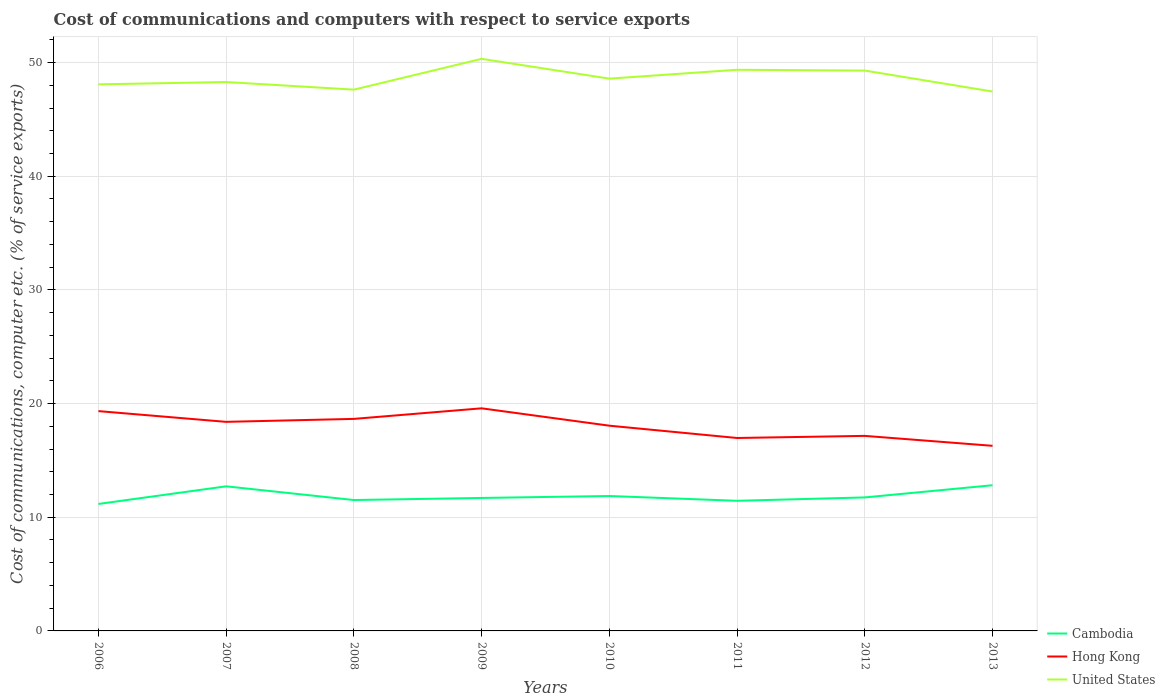How many different coloured lines are there?
Offer a terse response. 3. Does the line corresponding to Hong Kong intersect with the line corresponding to Cambodia?
Your response must be concise. No. Is the number of lines equal to the number of legend labels?
Make the answer very short. Yes. Across all years, what is the maximum cost of communications and computers in Hong Kong?
Your answer should be very brief. 16.28. What is the total cost of communications and computers in Cambodia in the graph?
Offer a very short reply. 0.07. What is the difference between the highest and the second highest cost of communications and computers in Hong Kong?
Provide a short and direct response. 3.3. What is the difference between the highest and the lowest cost of communications and computers in Hong Kong?
Provide a succinct answer. 5. Is the cost of communications and computers in Hong Kong strictly greater than the cost of communications and computers in Cambodia over the years?
Provide a short and direct response. No. How many lines are there?
Your answer should be compact. 3. How many years are there in the graph?
Provide a succinct answer. 8. What is the difference between two consecutive major ticks on the Y-axis?
Make the answer very short. 10. Does the graph contain any zero values?
Your answer should be very brief. No. How are the legend labels stacked?
Offer a very short reply. Vertical. What is the title of the graph?
Offer a terse response. Cost of communications and computers with respect to service exports. What is the label or title of the Y-axis?
Make the answer very short. Cost of communications, computer etc. (% of service exports). What is the Cost of communications, computer etc. (% of service exports) in Cambodia in 2006?
Provide a short and direct response. 11.17. What is the Cost of communications, computer etc. (% of service exports) of Hong Kong in 2006?
Provide a succinct answer. 19.34. What is the Cost of communications, computer etc. (% of service exports) of United States in 2006?
Your answer should be compact. 48.08. What is the Cost of communications, computer etc. (% of service exports) of Cambodia in 2007?
Offer a terse response. 12.72. What is the Cost of communications, computer etc. (% of service exports) of Hong Kong in 2007?
Give a very brief answer. 18.39. What is the Cost of communications, computer etc. (% of service exports) of United States in 2007?
Give a very brief answer. 48.29. What is the Cost of communications, computer etc. (% of service exports) of Cambodia in 2008?
Provide a short and direct response. 11.52. What is the Cost of communications, computer etc. (% of service exports) of Hong Kong in 2008?
Provide a short and direct response. 18.65. What is the Cost of communications, computer etc. (% of service exports) of United States in 2008?
Make the answer very short. 47.62. What is the Cost of communications, computer etc. (% of service exports) of Cambodia in 2009?
Your answer should be compact. 11.7. What is the Cost of communications, computer etc. (% of service exports) of Hong Kong in 2009?
Ensure brevity in your answer.  19.58. What is the Cost of communications, computer etc. (% of service exports) in United States in 2009?
Your response must be concise. 50.33. What is the Cost of communications, computer etc. (% of service exports) in Cambodia in 2010?
Provide a succinct answer. 11.87. What is the Cost of communications, computer etc. (% of service exports) of Hong Kong in 2010?
Offer a very short reply. 18.06. What is the Cost of communications, computer etc. (% of service exports) in United States in 2010?
Give a very brief answer. 48.59. What is the Cost of communications, computer etc. (% of service exports) of Cambodia in 2011?
Ensure brevity in your answer.  11.45. What is the Cost of communications, computer etc. (% of service exports) in Hong Kong in 2011?
Keep it short and to the point. 16.97. What is the Cost of communications, computer etc. (% of service exports) of United States in 2011?
Keep it short and to the point. 49.37. What is the Cost of communications, computer etc. (% of service exports) of Cambodia in 2012?
Your answer should be compact. 11.74. What is the Cost of communications, computer etc. (% of service exports) in Hong Kong in 2012?
Your response must be concise. 17.16. What is the Cost of communications, computer etc. (% of service exports) in United States in 2012?
Make the answer very short. 49.3. What is the Cost of communications, computer etc. (% of service exports) in Cambodia in 2013?
Your answer should be very brief. 12.82. What is the Cost of communications, computer etc. (% of service exports) of Hong Kong in 2013?
Make the answer very short. 16.28. What is the Cost of communications, computer etc. (% of service exports) in United States in 2013?
Provide a short and direct response. 47.45. Across all years, what is the maximum Cost of communications, computer etc. (% of service exports) of Cambodia?
Provide a short and direct response. 12.82. Across all years, what is the maximum Cost of communications, computer etc. (% of service exports) of Hong Kong?
Your answer should be very brief. 19.58. Across all years, what is the maximum Cost of communications, computer etc. (% of service exports) in United States?
Your answer should be very brief. 50.33. Across all years, what is the minimum Cost of communications, computer etc. (% of service exports) of Cambodia?
Ensure brevity in your answer.  11.17. Across all years, what is the minimum Cost of communications, computer etc. (% of service exports) of Hong Kong?
Keep it short and to the point. 16.28. Across all years, what is the minimum Cost of communications, computer etc. (% of service exports) of United States?
Ensure brevity in your answer.  47.45. What is the total Cost of communications, computer etc. (% of service exports) in Cambodia in the graph?
Make the answer very short. 94.98. What is the total Cost of communications, computer etc. (% of service exports) in Hong Kong in the graph?
Provide a succinct answer. 144.44. What is the total Cost of communications, computer etc. (% of service exports) of United States in the graph?
Your response must be concise. 389.03. What is the difference between the Cost of communications, computer etc. (% of service exports) of Cambodia in 2006 and that in 2007?
Keep it short and to the point. -1.55. What is the difference between the Cost of communications, computer etc. (% of service exports) in Hong Kong in 2006 and that in 2007?
Keep it short and to the point. 0.95. What is the difference between the Cost of communications, computer etc. (% of service exports) of United States in 2006 and that in 2007?
Provide a short and direct response. -0.21. What is the difference between the Cost of communications, computer etc. (% of service exports) in Cambodia in 2006 and that in 2008?
Offer a very short reply. -0.34. What is the difference between the Cost of communications, computer etc. (% of service exports) in Hong Kong in 2006 and that in 2008?
Provide a succinct answer. 0.68. What is the difference between the Cost of communications, computer etc. (% of service exports) in United States in 2006 and that in 2008?
Your answer should be very brief. 0.46. What is the difference between the Cost of communications, computer etc. (% of service exports) of Cambodia in 2006 and that in 2009?
Ensure brevity in your answer.  -0.53. What is the difference between the Cost of communications, computer etc. (% of service exports) in Hong Kong in 2006 and that in 2009?
Provide a short and direct response. -0.25. What is the difference between the Cost of communications, computer etc. (% of service exports) of United States in 2006 and that in 2009?
Offer a very short reply. -2.25. What is the difference between the Cost of communications, computer etc. (% of service exports) of Cambodia in 2006 and that in 2010?
Keep it short and to the point. -0.7. What is the difference between the Cost of communications, computer etc. (% of service exports) of Hong Kong in 2006 and that in 2010?
Ensure brevity in your answer.  1.28. What is the difference between the Cost of communications, computer etc. (% of service exports) of United States in 2006 and that in 2010?
Your answer should be very brief. -0.51. What is the difference between the Cost of communications, computer etc. (% of service exports) of Cambodia in 2006 and that in 2011?
Keep it short and to the point. -0.28. What is the difference between the Cost of communications, computer etc. (% of service exports) of Hong Kong in 2006 and that in 2011?
Your answer should be compact. 2.36. What is the difference between the Cost of communications, computer etc. (% of service exports) of United States in 2006 and that in 2011?
Provide a short and direct response. -1.28. What is the difference between the Cost of communications, computer etc. (% of service exports) in Cambodia in 2006 and that in 2012?
Offer a terse response. -0.57. What is the difference between the Cost of communications, computer etc. (% of service exports) in Hong Kong in 2006 and that in 2012?
Your answer should be compact. 2.18. What is the difference between the Cost of communications, computer etc. (% of service exports) of United States in 2006 and that in 2012?
Offer a terse response. -1.21. What is the difference between the Cost of communications, computer etc. (% of service exports) in Cambodia in 2006 and that in 2013?
Provide a short and direct response. -1.65. What is the difference between the Cost of communications, computer etc. (% of service exports) of Hong Kong in 2006 and that in 2013?
Your answer should be compact. 3.05. What is the difference between the Cost of communications, computer etc. (% of service exports) in United States in 2006 and that in 2013?
Your response must be concise. 0.63. What is the difference between the Cost of communications, computer etc. (% of service exports) of Cambodia in 2007 and that in 2008?
Ensure brevity in your answer.  1.21. What is the difference between the Cost of communications, computer etc. (% of service exports) of Hong Kong in 2007 and that in 2008?
Your response must be concise. -0.26. What is the difference between the Cost of communications, computer etc. (% of service exports) in United States in 2007 and that in 2008?
Offer a very short reply. 0.67. What is the difference between the Cost of communications, computer etc. (% of service exports) of Cambodia in 2007 and that in 2009?
Ensure brevity in your answer.  1.02. What is the difference between the Cost of communications, computer etc. (% of service exports) of Hong Kong in 2007 and that in 2009?
Make the answer very short. -1.19. What is the difference between the Cost of communications, computer etc. (% of service exports) in United States in 2007 and that in 2009?
Provide a short and direct response. -2.04. What is the difference between the Cost of communications, computer etc. (% of service exports) of Cambodia in 2007 and that in 2010?
Your answer should be very brief. 0.85. What is the difference between the Cost of communications, computer etc. (% of service exports) of Hong Kong in 2007 and that in 2010?
Offer a terse response. 0.34. What is the difference between the Cost of communications, computer etc. (% of service exports) in United States in 2007 and that in 2010?
Provide a succinct answer. -0.3. What is the difference between the Cost of communications, computer etc. (% of service exports) in Cambodia in 2007 and that in 2011?
Your answer should be compact. 1.27. What is the difference between the Cost of communications, computer etc. (% of service exports) of Hong Kong in 2007 and that in 2011?
Offer a terse response. 1.42. What is the difference between the Cost of communications, computer etc. (% of service exports) in United States in 2007 and that in 2011?
Provide a succinct answer. -1.08. What is the difference between the Cost of communications, computer etc. (% of service exports) in Cambodia in 2007 and that in 2012?
Provide a succinct answer. 0.98. What is the difference between the Cost of communications, computer etc. (% of service exports) in Hong Kong in 2007 and that in 2012?
Give a very brief answer. 1.23. What is the difference between the Cost of communications, computer etc. (% of service exports) in United States in 2007 and that in 2012?
Your answer should be very brief. -1.01. What is the difference between the Cost of communications, computer etc. (% of service exports) of Cambodia in 2007 and that in 2013?
Your answer should be compact. -0.1. What is the difference between the Cost of communications, computer etc. (% of service exports) in Hong Kong in 2007 and that in 2013?
Give a very brief answer. 2.11. What is the difference between the Cost of communications, computer etc. (% of service exports) of United States in 2007 and that in 2013?
Your response must be concise. 0.84. What is the difference between the Cost of communications, computer etc. (% of service exports) of Cambodia in 2008 and that in 2009?
Offer a terse response. -0.18. What is the difference between the Cost of communications, computer etc. (% of service exports) of Hong Kong in 2008 and that in 2009?
Provide a short and direct response. -0.93. What is the difference between the Cost of communications, computer etc. (% of service exports) in United States in 2008 and that in 2009?
Make the answer very short. -2.71. What is the difference between the Cost of communications, computer etc. (% of service exports) of Cambodia in 2008 and that in 2010?
Your answer should be very brief. -0.35. What is the difference between the Cost of communications, computer etc. (% of service exports) of Hong Kong in 2008 and that in 2010?
Offer a very short reply. 0.6. What is the difference between the Cost of communications, computer etc. (% of service exports) in United States in 2008 and that in 2010?
Your answer should be very brief. -0.97. What is the difference between the Cost of communications, computer etc. (% of service exports) in Cambodia in 2008 and that in 2011?
Your response must be concise. 0.07. What is the difference between the Cost of communications, computer etc. (% of service exports) of Hong Kong in 2008 and that in 2011?
Keep it short and to the point. 1.68. What is the difference between the Cost of communications, computer etc. (% of service exports) of United States in 2008 and that in 2011?
Ensure brevity in your answer.  -1.75. What is the difference between the Cost of communications, computer etc. (% of service exports) of Cambodia in 2008 and that in 2012?
Keep it short and to the point. -0.23. What is the difference between the Cost of communications, computer etc. (% of service exports) of Hong Kong in 2008 and that in 2012?
Offer a very short reply. 1.49. What is the difference between the Cost of communications, computer etc. (% of service exports) in United States in 2008 and that in 2012?
Make the answer very short. -1.68. What is the difference between the Cost of communications, computer etc. (% of service exports) of Cambodia in 2008 and that in 2013?
Keep it short and to the point. -1.3. What is the difference between the Cost of communications, computer etc. (% of service exports) in Hong Kong in 2008 and that in 2013?
Your answer should be very brief. 2.37. What is the difference between the Cost of communications, computer etc. (% of service exports) in United States in 2008 and that in 2013?
Your answer should be compact. 0.17. What is the difference between the Cost of communications, computer etc. (% of service exports) of Cambodia in 2009 and that in 2010?
Keep it short and to the point. -0.17. What is the difference between the Cost of communications, computer etc. (% of service exports) in Hong Kong in 2009 and that in 2010?
Offer a very short reply. 1.53. What is the difference between the Cost of communications, computer etc. (% of service exports) in United States in 2009 and that in 2010?
Keep it short and to the point. 1.74. What is the difference between the Cost of communications, computer etc. (% of service exports) in Cambodia in 2009 and that in 2011?
Make the answer very short. 0.25. What is the difference between the Cost of communications, computer etc. (% of service exports) in Hong Kong in 2009 and that in 2011?
Your response must be concise. 2.61. What is the difference between the Cost of communications, computer etc. (% of service exports) in United States in 2009 and that in 2011?
Provide a short and direct response. 0.96. What is the difference between the Cost of communications, computer etc. (% of service exports) in Cambodia in 2009 and that in 2012?
Your answer should be compact. -0.05. What is the difference between the Cost of communications, computer etc. (% of service exports) of Hong Kong in 2009 and that in 2012?
Offer a terse response. 2.42. What is the difference between the Cost of communications, computer etc. (% of service exports) in United States in 2009 and that in 2012?
Ensure brevity in your answer.  1.03. What is the difference between the Cost of communications, computer etc. (% of service exports) of Cambodia in 2009 and that in 2013?
Make the answer very short. -1.12. What is the difference between the Cost of communications, computer etc. (% of service exports) of Hong Kong in 2009 and that in 2013?
Give a very brief answer. 3.3. What is the difference between the Cost of communications, computer etc. (% of service exports) of United States in 2009 and that in 2013?
Your answer should be compact. 2.88. What is the difference between the Cost of communications, computer etc. (% of service exports) of Cambodia in 2010 and that in 2011?
Make the answer very short. 0.42. What is the difference between the Cost of communications, computer etc. (% of service exports) of Hong Kong in 2010 and that in 2011?
Your response must be concise. 1.08. What is the difference between the Cost of communications, computer etc. (% of service exports) of United States in 2010 and that in 2011?
Your answer should be compact. -0.78. What is the difference between the Cost of communications, computer etc. (% of service exports) of Cambodia in 2010 and that in 2012?
Provide a short and direct response. 0.12. What is the difference between the Cost of communications, computer etc. (% of service exports) of Hong Kong in 2010 and that in 2012?
Your answer should be very brief. 0.9. What is the difference between the Cost of communications, computer etc. (% of service exports) in United States in 2010 and that in 2012?
Keep it short and to the point. -0.71. What is the difference between the Cost of communications, computer etc. (% of service exports) in Cambodia in 2010 and that in 2013?
Give a very brief answer. -0.95. What is the difference between the Cost of communications, computer etc. (% of service exports) in Hong Kong in 2010 and that in 2013?
Offer a very short reply. 1.77. What is the difference between the Cost of communications, computer etc. (% of service exports) in United States in 2010 and that in 2013?
Provide a short and direct response. 1.14. What is the difference between the Cost of communications, computer etc. (% of service exports) in Cambodia in 2011 and that in 2012?
Ensure brevity in your answer.  -0.3. What is the difference between the Cost of communications, computer etc. (% of service exports) in Hong Kong in 2011 and that in 2012?
Ensure brevity in your answer.  -0.19. What is the difference between the Cost of communications, computer etc. (% of service exports) of United States in 2011 and that in 2012?
Your answer should be very brief. 0.07. What is the difference between the Cost of communications, computer etc. (% of service exports) of Cambodia in 2011 and that in 2013?
Offer a terse response. -1.37. What is the difference between the Cost of communications, computer etc. (% of service exports) of Hong Kong in 2011 and that in 2013?
Your answer should be compact. 0.69. What is the difference between the Cost of communications, computer etc. (% of service exports) of United States in 2011 and that in 2013?
Provide a succinct answer. 1.91. What is the difference between the Cost of communications, computer etc. (% of service exports) in Cambodia in 2012 and that in 2013?
Make the answer very short. -1.07. What is the difference between the Cost of communications, computer etc. (% of service exports) in Hong Kong in 2012 and that in 2013?
Ensure brevity in your answer.  0.87. What is the difference between the Cost of communications, computer etc. (% of service exports) of United States in 2012 and that in 2013?
Offer a terse response. 1.84. What is the difference between the Cost of communications, computer etc. (% of service exports) of Cambodia in 2006 and the Cost of communications, computer etc. (% of service exports) of Hong Kong in 2007?
Your response must be concise. -7.22. What is the difference between the Cost of communications, computer etc. (% of service exports) of Cambodia in 2006 and the Cost of communications, computer etc. (% of service exports) of United States in 2007?
Your answer should be compact. -37.12. What is the difference between the Cost of communications, computer etc. (% of service exports) of Hong Kong in 2006 and the Cost of communications, computer etc. (% of service exports) of United States in 2007?
Make the answer very short. -28.95. What is the difference between the Cost of communications, computer etc. (% of service exports) of Cambodia in 2006 and the Cost of communications, computer etc. (% of service exports) of Hong Kong in 2008?
Keep it short and to the point. -7.48. What is the difference between the Cost of communications, computer etc. (% of service exports) of Cambodia in 2006 and the Cost of communications, computer etc. (% of service exports) of United States in 2008?
Offer a terse response. -36.45. What is the difference between the Cost of communications, computer etc. (% of service exports) of Hong Kong in 2006 and the Cost of communications, computer etc. (% of service exports) of United States in 2008?
Your answer should be compact. -28.28. What is the difference between the Cost of communications, computer etc. (% of service exports) in Cambodia in 2006 and the Cost of communications, computer etc. (% of service exports) in Hong Kong in 2009?
Provide a short and direct response. -8.41. What is the difference between the Cost of communications, computer etc. (% of service exports) of Cambodia in 2006 and the Cost of communications, computer etc. (% of service exports) of United States in 2009?
Give a very brief answer. -39.16. What is the difference between the Cost of communications, computer etc. (% of service exports) in Hong Kong in 2006 and the Cost of communications, computer etc. (% of service exports) in United States in 2009?
Ensure brevity in your answer.  -30.99. What is the difference between the Cost of communications, computer etc. (% of service exports) in Cambodia in 2006 and the Cost of communications, computer etc. (% of service exports) in Hong Kong in 2010?
Give a very brief answer. -6.88. What is the difference between the Cost of communications, computer etc. (% of service exports) of Cambodia in 2006 and the Cost of communications, computer etc. (% of service exports) of United States in 2010?
Offer a terse response. -37.42. What is the difference between the Cost of communications, computer etc. (% of service exports) in Hong Kong in 2006 and the Cost of communications, computer etc. (% of service exports) in United States in 2010?
Offer a terse response. -29.25. What is the difference between the Cost of communications, computer etc. (% of service exports) in Cambodia in 2006 and the Cost of communications, computer etc. (% of service exports) in Hong Kong in 2011?
Keep it short and to the point. -5.8. What is the difference between the Cost of communications, computer etc. (% of service exports) of Cambodia in 2006 and the Cost of communications, computer etc. (% of service exports) of United States in 2011?
Ensure brevity in your answer.  -38.19. What is the difference between the Cost of communications, computer etc. (% of service exports) in Hong Kong in 2006 and the Cost of communications, computer etc. (% of service exports) in United States in 2011?
Keep it short and to the point. -30.03. What is the difference between the Cost of communications, computer etc. (% of service exports) in Cambodia in 2006 and the Cost of communications, computer etc. (% of service exports) in Hong Kong in 2012?
Offer a terse response. -5.99. What is the difference between the Cost of communications, computer etc. (% of service exports) of Cambodia in 2006 and the Cost of communications, computer etc. (% of service exports) of United States in 2012?
Ensure brevity in your answer.  -38.13. What is the difference between the Cost of communications, computer etc. (% of service exports) in Hong Kong in 2006 and the Cost of communications, computer etc. (% of service exports) in United States in 2012?
Provide a short and direct response. -29.96. What is the difference between the Cost of communications, computer etc. (% of service exports) of Cambodia in 2006 and the Cost of communications, computer etc. (% of service exports) of Hong Kong in 2013?
Give a very brief answer. -5.11. What is the difference between the Cost of communications, computer etc. (% of service exports) in Cambodia in 2006 and the Cost of communications, computer etc. (% of service exports) in United States in 2013?
Your answer should be very brief. -36.28. What is the difference between the Cost of communications, computer etc. (% of service exports) of Hong Kong in 2006 and the Cost of communications, computer etc. (% of service exports) of United States in 2013?
Ensure brevity in your answer.  -28.12. What is the difference between the Cost of communications, computer etc. (% of service exports) of Cambodia in 2007 and the Cost of communications, computer etc. (% of service exports) of Hong Kong in 2008?
Provide a short and direct response. -5.93. What is the difference between the Cost of communications, computer etc. (% of service exports) of Cambodia in 2007 and the Cost of communications, computer etc. (% of service exports) of United States in 2008?
Give a very brief answer. -34.9. What is the difference between the Cost of communications, computer etc. (% of service exports) of Hong Kong in 2007 and the Cost of communications, computer etc. (% of service exports) of United States in 2008?
Offer a very short reply. -29.23. What is the difference between the Cost of communications, computer etc. (% of service exports) in Cambodia in 2007 and the Cost of communications, computer etc. (% of service exports) in Hong Kong in 2009?
Provide a short and direct response. -6.86. What is the difference between the Cost of communications, computer etc. (% of service exports) in Cambodia in 2007 and the Cost of communications, computer etc. (% of service exports) in United States in 2009?
Your response must be concise. -37.61. What is the difference between the Cost of communications, computer etc. (% of service exports) in Hong Kong in 2007 and the Cost of communications, computer etc. (% of service exports) in United States in 2009?
Make the answer very short. -31.94. What is the difference between the Cost of communications, computer etc. (% of service exports) in Cambodia in 2007 and the Cost of communications, computer etc. (% of service exports) in Hong Kong in 2010?
Offer a very short reply. -5.33. What is the difference between the Cost of communications, computer etc. (% of service exports) in Cambodia in 2007 and the Cost of communications, computer etc. (% of service exports) in United States in 2010?
Make the answer very short. -35.87. What is the difference between the Cost of communications, computer etc. (% of service exports) in Hong Kong in 2007 and the Cost of communications, computer etc. (% of service exports) in United States in 2010?
Provide a succinct answer. -30.2. What is the difference between the Cost of communications, computer etc. (% of service exports) of Cambodia in 2007 and the Cost of communications, computer etc. (% of service exports) of Hong Kong in 2011?
Keep it short and to the point. -4.25. What is the difference between the Cost of communications, computer etc. (% of service exports) in Cambodia in 2007 and the Cost of communications, computer etc. (% of service exports) in United States in 2011?
Your answer should be very brief. -36.64. What is the difference between the Cost of communications, computer etc. (% of service exports) of Hong Kong in 2007 and the Cost of communications, computer etc. (% of service exports) of United States in 2011?
Your answer should be compact. -30.97. What is the difference between the Cost of communications, computer etc. (% of service exports) in Cambodia in 2007 and the Cost of communications, computer etc. (% of service exports) in Hong Kong in 2012?
Give a very brief answer. -4.44. What is the difference between the Cost of communications, computer etc. (% of service exports) of Cambodia in 2007 and the Cost of communications, computer etc. (% of service exports) of United States in 2012?
Your response must be concise. -36.58. What is the difference between the Cost of communications, computer etc. (% of service exports) in Hong Kong in 2007 and the Cost of communications, computer etc. (% of service exports) in United States in 2012?
Ensure brevity in your answer.  -30.9. What is the difference between the Cost of communications, computer etc. (% of service exports) of Cambodia in 2007 and the Cost of communications, computer etc. (% of service exports) of Hong Kong in 2013?
Give a very brief answer. -3.56. What is the difference between the Cost of communications, computer etc. (% of service exports) of Cambodia in 2007 and the Cost of communications, computer etc. (% of service exports) of United States in 2013?
Make the answer very short. -34.73. What is the difference between the Cost of communications, computer etc. (% of service exports) of Hong Kong in 2007 and the Cost of communications, computer etc. (% of service exports) of United States in 2013?
Provide a succinct answer. -29.06. What is the difference between the Cost of communications, computer etc. (% of service exports) of Cambodia in 2008 and the Cost of communications, computer etc. (% of service exports) of Hong Kong in 2009?
Give a very brief answer. -8.07. What is the difference between the Cost of communications, computer etc. (% of service exports) of Cambodia in 2008 and the Cost of communications, computer etc. (% of service exports) of United States in 2009?
Your answer should be very brief. -38.81. What is the difference between the Cost of communications, computer etc. (% of service exports) in Hong Kong in 2008 and the Cost of communications, computer etc. (% of service exports) in United States in 2009?
Your answer should be very brief. -31.68. What is the difference between the Cost of communications, computer etc. (% of service exports) of Cambodia in 2008 and the Cost of communications, computer etc. (% of service exports) of Hong Kong in 2010?
Ensure brevity in your answer.  -6.54. What is the difference between the Cost of communications, computer etc. (% of service exports) in Cambodia in 2008 and the Cost of communications, computer etc. (% of service exports) in United States in 2010?
Offer a terse response. -37.07. What is the difference between the Cost of communications, computer etc. (% of service exports) of Hong Kong in 2008 and the Cost of communications, computer etc. (% of service exports) of United States in 2010?
Your answer should be very brief. -29.94. What is the difference between the Cost of communications, computer etc. (% of service exports) of Cambodia in 2008 and the Cost of communications, computer etc. (% of service exports) of Hong Kong in 2011?
Give a very brief answer. -5.46. What is the difference between the Cost of communications, computer etc. (% of service exports) of Cambodia in 2008 and the Cost of communications, computer etc. (% of service exports) of United States in 2011?
Provide a short and direct response. -37.85. What is the difference between the Cost of communications, computer etc. (% of service exports) of Hong Kong in 2008 and the Cost of communications, computer etc. (% of service exports) of United States in 2011?
Provide a succinct answer. -30.71. What is the difference between the Cost of communications, computer etc. (% of service exports) in Cambodia in 2008 and the Cost of communications, computer etc. (% of service exports) in Hong Kong in 2012?
Your answer should be very brief. -5.64. What is the difference between the Cost of communications, computer etc. (% of service exports) in Cambodia in 2008 and the Cost of communications, computer etc. (% of service exports) in United States in 2012?
Give a very brief answer. -37.78. What is the difference between the Cost of communications, computer etc. (% of service exports) of Hong Kong in 2008 and the Cost of communications, computer etc. (% of service exports) of United States in 2012?
Give a very brief answer. -30.64. What is the difference between the Cost of communications, computer etc. (% of service exports) in Cambodia in 2008 and the Cost of communications, computer etc. (% of service exports) in Hong Kong in 2013?
Offer a terse response. -4.77. What is the difference between the Cost of communications, computer etc. (% of service exports) in Cambodia in 2008 and the Cost of communications, computer etc. (% of service exports) in United States in 2013?
Ensure brevity in your answer.  -35.94. What is the difference between the Cost of communications, computer etc. (% of service exports) in Hong Kong in 2008 and the Cost of communications, computer etc. (% of service exports) in United States in 2013?
Provide a short and direct response. -28.8. What is the difference between the Cost of communications, computer etc. (% of service exports) of Cambodia in 2009 and the Cost of communications, computer etc. (% of service exports) of Hong Kong in 2010?
Make the answer very short. -6.36. What is the difference between the Cost of communications, computer etc. (% of service exports) of Cambodia in 2009 and the Cost of communications, computer etc. (% of service exports) of United States in 2010?
Keep it short and to the point. -36.89. What is the difference between the Cost of communications, computer etc. (% of service exports) in Hong Kong in 2009 and the Cost of communications, computer etc. (% of service exports) in United States in 2010?
Ensure brevity in your answer.  -29.01. What is the difference between the Cost of communications, computer etc. (% of service exports) of Cambodia in 2009 and the Cost of communications, computer etc. (% of service exports) of Hong Kong in 2011?
Your answer should be very brief. -5.28. What is the difference between the Cost of communications, computer etc. (% of service exports) of Cambodia in 2009 and the Cost of communications, computer etc. (% of service exports) of United States in 2011?
Offer a very short reply. -37.67. What is the difference between the Cost of communications, computer etc. (% of service exports) in Hong Kong in 2009 and the Cost of communications, computer etc. (% of service exports) in United States in 2011?
Offer a very short reply. -29.78. What is the difference between the Cost of communications, computer etc. (% of service exports) in Cambodia in 2009 and the Cost of communications, computer etc. (% of service exports) in Hong Kong in 2012?
Provide a short and direct response. -5.46. What is the difference between the Cost of communications, computer etc. (% of service exports) in Cambodia in 2009 and the Cost of communications, computer etc. (% of service exports) in United States in 2012?
Your answer should be compact. -37.6. What is the difference between the Cost of communications, computer etc. (% of service exports) in Hong Kong in 2009 and the Cost of communications, computer etc. (% of service exports) in United States in 2012?
Make the answer very short. -29.71. What is the difference between the Cost of communications, computer etc. (% of service exports) of Cambodia in 2009 and the Cost of communications, computer etc. (% of service exports) of Hong Kong in 2013?
Ensure brevity in your answer.  -4.59. What is the difference between the Cost of communications, computer etc. (% of service exports) in Cambodia in 2009 and the Cost of communications, computer etc. (% of service exports) in United States in 2013?
Your response must be concise. -35.76. What is the difference between the Cost of communications, computer etc. (% of service exports) of Hong Kong in 2009 and the Cost of communications, computer etc. (% of service exports) of United States in 2013?
Your answer should be very brief. -27.87. What is the difference between the Cost of communications, computer etc. (% of service exports) in Cambodia in 2010 and the Cost of communications, computer etc. (% of service exports) in Hong Kong in 2011?
Keep it short and to the point. -5.1. What is the difference between the Cost of communications, computer etc. (% of service exports) of Cambodia in 2010 and the Cost of communications, computer etc. (% of service exports) of United States in 2011?
Provide a short and direct response. -37.5. What is the difference between the Cost of communications, computer etc. (% of service exports) in Hong Kong in 2010 and the Cost of communications, computer etc. (% of service exports) in United States in 2011?
Offer a terse response. -31.31. What is the difference between the Cost of communications, computer etc. (% of service exports) of Cambodia in 2010 and the Cost of communications, computer etc. (% of service exports) of Hong Kong in 2012?
Ensure brevity in your answer.  -5.29. What is the difference between the Cost of communications, computer etc. (% of service exports) of Cambodia in 2010 and the Cost of communications, computer etc. (% of service exports) of United States in 2012?
Ensure brevity in your answer.  -37.43. What is the difference between the Cost of communications, computer etc. (% of service exports) of Hong Kong in 2010 and the Cost of communications, computer etc. (% of service exports) of United States in 2012?
Offer a terse response. -31.24. What is the difference between the Cost of communications, computer etc. (% of service exports) in Cambodia in 2010 and the Cost of communications, computer etc. (% of service exports) in Hong Kong in 2013?
Offer a terse response. -4.42. What is the difference between the Cost of communications, computer etc. (% of service exports) of Cambodia in 2010 and the Cost of communications, computer etc. (% of service exports) of United States in 2013?
Offer a terse response. -35.58. What is the difference between the Cost of communications, computer etc. (% of service exports) in Hong Kong in 2010 and the Cost of communications, computer etc. (% of service exports) in United States in 2013?
Your response must be concise. -29.4. What is the difference between the Cost of communications, computer etc. (% of service exports) in Cambodia in 2011 and the Cost of communications, computer etc. (% of service exports) in Hong Kong in 2012?
Offer a terse response. -5.71. What is the difference between the Cost of communications, computer etc. (% of service exports) of Cambodia in 2011 and the Cost of communications, computer etc. (% of service exports) of United States in 2012?
Keep it short and to the point. -37.85. What is the difference between the Cost of communications, computer etc. (% of service exports) in Hong Kong in 2011 and the Cost of communications, computer etc. (% of service exports) in United States in 2012?
Keep it short and to the point. -32.32. What is the difference between the Cost of communications, computer etc. (% of service exports) of Cambodia in 2011 and the Cost of communications, computer etc. (% of service exports) of Hong Kong in 2013?
Make the answer very short. -4.84. What is the difference between the Cost of communications, computer etc. (% of service exports) in Cambodia in 2011 and the Cost of communications, computer etc. (% of service exports) in United States in 2013?
Give a very brief answer. -36.01. What is the difference between the Cost of communications, computer etc. (% of service exports) in Hong Kong in 2011 and the Cost of communications, computer etc. (% of service exports) in United States in 2013?
Your answer should be compact. -30.48. What is the difference between the Cost of communications, computer etc. (% of service exports) in Cambodia in 2012 and the Cost of communications, computer etc. (% of service exports) in Hong Kong in 2013?
Give a very brief answer. -4.54. What is the difference between the Cost of communications, computer etc. (% of service exports) in Cambodia in 2012 and the Cost of communications, computer etc. (% of service exports) in United States in 2013?
Your answer should be compact. -35.71. What is the difference between the Cost of communications, computer etc. (% of service exports) of Hong Kong in 2012 and the Cost of communications, computer etc. (% of service exports) of United States in 2013?
Give a very brief answer. -30.29. What is the average Cost of communications, computer etc. (% of service exports) of Cambodia per year?
Provide a succinct answer. 11.87. What is the average Cost of communications, computer etc. (% of service exports) of Hong Kong per year?
Provide a short and direct response. 18.05. What is the average Cost of communications, computer etc. (% of service exports) of United States per year?
Your response must be concise. 48.63. In the year 2006, what is the difference between the Cost of communications, computer etc. (% of service exports) of Cambodia and Cost of communications, computer etc. (% of service exports) of Hong Kong?
Provide a short and direct response. -8.17. In the year 2006, what is the difference between the Cost of communications, computer etc. (% of service exports) of Cambodia and Cost of communications, computer etc. (% of service exports) of United States?
Ensure brevity in your answer.  -36.91. In the year 2006, what is the difference between the Cost of communications, computer etc. (% of service exports) in Hong Kong and Cost of communications, computer etc. (% of service exports) in United States?
Keep it short and to the point. -28.75. In the year 2007, what is the difference between the Cost of communications, computer etc. (% of service exports) in Cambodia and Cost of communications, computer etc. (% of service exports) in Hong Kong?
Keep it short and to the point. -5.67. In the year 2007, what is the difference between the Cost of communications, computer etc. (% of service exports) in Cambodia and Cost of communications, computer etc. (% of service exports) in United States?
Keep it short and to the point. -35.57. In the year 2007, what is the difference between the Cost of communications, computer etc. (% of service exports) in Hong Kong and Cost of communications, computer etc. (% of service exports) in United States?
Your answer should be compact. -29.9. In the year 2008, what is the difference between the Cost of communications, computer etc. (% of service exports) of Cambodia and Cost of communications, computer etc. (% of service exports) of Hong Kong?
Your response must be concise. -7.14. In the year 2008, what is the difference between the Cost of communications, computer etc. (% of service exports) in Cambodia and Cost of communications, computer etc. (% of service exports) in United States?
Your response must be concise. -36.1. In the year 2008, what is the difference between the Cost of communications, computer etc. (% of service exports) of Hong Kong and Cost of communications, computer etc. (% of service exports) of United States?
Offer a very short reply. -28.97. In the year 2009, what is the difference between the Cost of communications, computer etc. (% of service exports) in Cambodia and Cost of communications, computer etc. (% of service exports) in Hong Kong?
Offer a very short reply. -7.89. In the year 2009, what is the difference between the Cost of communications, computer etc. (% of service exports) of Cambodia and Cost of communications, computer etc. (% of service exports) of United States?
Provide a succinct answer. -38.63. In the year 2009, what is the difference between the Cost of communications, computer etc. (% of service exports) of Hong Kong and Cost of communications, computer etc. (% of service exports) of United States?
Give a very brief answer. -30.75. In the year 2010, what is the difference between the Cost of communications, computer etc. (% of service exports) of Cambodia and Cost of communications, computer etc. (% of service exports) of Hong Kong?
Offer a terse response. -6.19. In the year 2010, what is the difference between the Cost of communications, computer etc. (% of service exports) in Cambodia and Cost of communications, computer etc. (% of service exports) in United States?
Your answer should be very brief. -36.72. In the year 2010, what is the difference between the Cost of communications, computer etc. (% of service exports) of Hong Kong and Cost of communications, computer etc. (% of service exports) of United States?
Provide a succinct answer. -30.53. In the year 2011, what is the difference between the Cost of communications, computer etc. (% of service exports) of Cambodia and Cost of communications, computer etc. (% of service exports) of Hong Kong?
Your answer should be compact. -5.53. In the year 2011, what is the difference between the Cost of communications, computer etc. (% of service exports) of Cambodia and Cost of communications, computer etc. (% of service exports) of United States?
Your answer should be compact. -37.92. In the year 2011, what is the difference between the Cost of communications, computer etc. (% of service exports) of Hong Kong and Cost of communications, computer etc. (% of service exports) of United States?
Provide a succinct answer. -32.39. In the year 2012, what is the difference between the Cost of communications, computer etc. (% of service exports) of Cambodia and Cost of communications, computer etc. (% of service exports) of Hong Kong?
Keep it short and to the point. -5.41. In the year 2012, what is the difference between the Cost of communications, computer etc. (% of service exports) of Cambodia and Cost of communications, computer etc. (% of service exports) of United States?
Make the answer very short. -37.55. In the year 2012, what is the difference between the Cost of communications, computer etc. (% of service exports) of Hong Kong and Cost of communications, computer etc. (% of service exports) of United States?
Offer a very short reply. -32.14. In the year 2013, what is the difference between the Cost of communications, computer etc. (% of service exports) of Cambodia and Cost of communications, computer etc. (% of service exports) of Hong Kong?
Your response must be concise. -3.47. In the year 2013, what is the difference between the Cost of communications, computer etc. (% of service exports) of Cambodia and Cost of communications, computer etc. (% of service exports) of United States?
Make the answer very short. -34.64. In the year 2013, what is the difference between the Cost of communications, computer etc. (% of service exports) in Hong Kong and Cost of communications, computer etc. (% of service exports) in United States?
Keep it short and to the point. -31.17. What is the ratio of the Cost of communications, computer etc. (% of service exports) of Cambodia in 2006 to that in 2007?
Make the answer very short. 0.88. What is the ratio of the Cost of communications, computer etc. (% of service exports) of Hong Kong in 2006 to that in 2007?
Provide a short and direct response. 1.05. What is the ratio of the Cost of communications, computer etc. (% of service exports) of United States in 2006 to that in 2007?
Keep it short and to the point. 1. What is the ratio of the Cost of communications, computer etc. (% of service exports) of Cambodia in 2006 to that in 2008?
Make the answer very short. 0.97. What is the ratio of the Cost of communications, computer etc. (% of service exports) of Hong Kong in 2006 to that in 2008?
Provide a succinct answer. 1.04. What is the ratio of the Cost of communications, computer etc. (% of service exports) of United States in 2006 to that in 2008?
Offer a terse response. 1.01. What is the ratio of the Cost of communications, computer etc. (% of service exports) in Cambodia in 2006 to that in 2009?
Your response must be concise. 0.95. What is the ratio of the Cost of communications, computer etc. (% of service exports) of Hong Kong in 2006 to that in 2009?
Make the answer very short. 0.99. What is the ratio of the Cost of communications, computer etc. (% of service exports) of United States in 2006 to that in 2009?
Provide a short and direct response. 0.96. What is the ratio of the Cost of communications, computer etc. (% of service exports) in Cambodia in 2006 to that in 2010?
Provide a short and direct response. 0.94. What is the ratio of the Cost of communications, computer etc. (% of service exports) of Hong Kong in 2006 to that in 2010?
Your answer should be compact. 1.07. What is the ratio of the Cost of communications, computer etc. (% of service exports) in United States in 2006 to that in 2010?
Give a very brief answer. 0.99. What is the ratio of the Cost of communications, computer etc. (% of service exports) of Cambodia in 2006 to that in 2011?
Offer a terse response. 0.98. What is the ratio of the Cost of communications, computer etc. (% of service exports) of Hong Kong in 2006 to that in 2011?
Give a very brief answer. 1.14. What is the ratio of the Cost of communications, computer etc. (% of service exports) of Cambodia in 2006 to that in 2012?
Give a very brief answer. 0.95. What is the ratio of the Cost of communications, computer etc. (% of service exports) of Hong Kong in 2006 to that in 2012?
Provide a short and direct response. 1.13. What is the ratio of the Cost of communications, computer etc. (% of service exports) of United States in 2006 to that in 2012?
Keep it short and to the point. 0.98. What is the ratio of the Cost of communications, computer etc. (% of service exports) in Cambodia in 2006 to that in 2013?
Provide a succinct answer. 0.87. What is the ratio of the Cost of communications, computer etc. (% of service exports) in Hong Kong in 2006 to that in 2013?
Your answer should be compact. 1.19. What is the ratio of the Cost of communications, computer etc. (% of service exports) in United States in 2006 to that in 2013?
Your answer should be compact. 1.01. What is the ratio of the Cost of communications, computer etc. (% of service exports) in Cambodia in 2007 to that in 2008?
Your answer should be very brief. 1.1. What is the ratio of the Cost of communications, computer etc. (% of service exports) in United States in 2007 to that in 2008?
Provide a succinct answer. 1.01. What is the ratio of the Cost of communications, computer etc. (% of service exports) of Cambodia in 2007 to that in 2009?
Your answer should be very brief. 1.09. What is the ratio of the Cost of communications, computer etc. (% of service exports) in Hong Kong in 2007 to that in 2009?
Your response must be concise. 0.94. What is the ratio of the Cost of communications, computer etc. (% of service exports) of United States in 2007 to that in 2009?
Your answer should be very brief. 0.96. What is the ratio of the Cost of communications, computer etc. (% of service exports) in Cambodia in 2007 to that in 2010?
Give a very brief answer. 1.07. What is the ratio of the Cost of communications, computer etc. (% of service exports) in Hong Kong in 2007 to that in 2010?
Make the answer very short. 1.02. What is the ratio of the Cost of communications, computer etc. (% of service exports) of United States in 2007 to that in 2010?
Provide a succinct answer. 0.99. What is the ratio of the Cost of communications, computer etc. (% of service exports) in Cambodia in 2007 to that in 2011?
Keep it short and to the point. 1.11. What is the ratio of the Cost of communications, computer etc. (% of service exports) in Hong Kong in 2007 to that in 2011?
Your response must be concise. 1.08. What is the ratio of the Cost of communications, computer etc. (% of service exports) in United States in 2007 to that in 2011?
Provide a short and direct response. 0.98. What is the ratio of the Cost of communications, computer etc. (% of service exports) of Cambodia in 2007 to that in 2012?
Your answer should be very brief. 1.08. What is the ratio of the Cost of communications, computer etc. (% of service exports) of Hong Kong in 2007 to that in 2012?
Offer a terse response. 1.07. What is the ratio of the Cost of communications, computer etc. (% of service exports) in United States in 2007 to that in 2012?
Provide a short and direct response. 0.98. What is the ratio of the Cost of communications, computer etc. (% of service exports) of Cambodia in 2007 to that in 2013?
Offer a very short reply. 0.99. What is the ratio of the Cost of communications, computer etc. (% of service exports) in Hong Kong in 2007 to that in 2013?
Make the answer very short. 1.13. What is the ratio of the Cost of communications, computer etc. (% of service exports) of United States in 2007 to that in 2013?
Provide a short and direct response. 1.02. What is the ratio of the Cost of communications, computer etc. (% of service exports) in Cambodia in 2008 to that in 2009?
Offer a terse response. 0.98. What is the ratio of the Cost of communications, computer etc. (% of service exports) of Hong Kong in 2008 to that in 2009?
Provide a succinct answer. 0.95. What is the ratio of the Cost of communications, computer etc. (% of service exports) in United States in 2008 to that in 2009?
Provide a short and direct response. 0.95. What is the ratio of the Cost of communications, computer etc. (% of service exports) of Cambodia in 2008 to that in 2010?
Provide a short and direct response. 0.97. What is the ratio of the Cost of communications, computer etc. (% of service exports) in Hong Kong in 2008 to that in 2010?
Your response must be concise. 1.03. What is the ratio of the Cost of communications, computer etc. (% of service exports) of Cambodia in 2008 to that in 2011?
Your answer should be very brief. 1.01. What is the ratio of the Cost of communications, computer etc. (% of service exports) of Hong Kong in 2008 to that in 2011?
Your response must be concise. 1.1. What is the ratio of the Cost of communications, computer etc. (% of service exports) of United States in 2008 to that in 2011?
Keep it short and to the point. 0.96. What is the ratio of the Cost of communications, computer etc. (% of service exports) of Cambodia in 2008 to that in 2012?
Make the answer very short. 0.98. What is the ratio of the Cost of communications, computer etc. (% of service exports) of Hong Kong in 2008 to that in 2012?
Your answer should be very brief. 1.09. What is the ratio of the Cost of communications, computer etc. (% of service exports) in Cambodia in 2008 to that in 2013?
Give a very brief answer. 0.9. What is the ratio of the Cost of communications, computer etc. (% of service exports) in Hong Kong in 2008 to that in 2013?
Give a very brief answer. 1.15. What is the ratio of the Cost of communications, computer etc. (% of service exports) of United States in 2008 to that in 2013?
Make the answer very short. 1. What is the ratio of the Cost of communications, computer etc. (% of service exports) in Cambodia in 2009 to that in 2010?
Ensure brevity in your answer.  0.99. What is the ratio of the Cost of communications, computer etc. (% of service exports) of Hong Kong in 2009 to that in 2010?
Offer a very short reply. 1.08. What is the ratio of the Cost of communications, computer etc. (% of service exports) in United States in 2009 to that in 2010?
Your answer should be compact. 1.04. What is the ratio of the Cost of communications, computer etc. (% of service exports) in Cambodia in 2009 to that in 2011?
Make the answer very short. 1.02. What is the ratio of the Cost of communications, computer etc. (% of service exports) of Hong Kong in 2009 to that in 2011?
Your answer should be compact. 1.15. What is the ratio of the Cost of communications, computer etc. (% of service exports) in United States in 2009 to that in 2011?
Provide a short and direct response. 1.02. What is the ratio of the Cost of communications, computer etc. (% of service exports) of Hong Kong in 2009 to that in 2012?
Ensure brevity in your answer.  1.14. What is the ratio of the Cost of communications, computer etc. (% of service exports) in United States in 2009 to that in 2012?
Keep it short and to the point. 1.02. What is the ratio of the Cost of communications, computer etc. (% of service exports) in Cambodia in 2009 to that in 2013?
Keep it short and to the point. 0.91. What is the ratio of the Cost of communications, computer etc. (% of service exports) in Hong Kong in 2009 to that in 2013?
Your answer should be compact. 1.2. What is the ratio of the Cost of communications, computer etc. (% of service exports) in United States in 2009 to that in 2013?
Your answer should be compact. 1.06. What is the ratio of the Cost of communications, computer etc. (% of service exports) of Cambodia in 2010 to that in 2011?
Provide a short and direct response. 1.04. What is the ratio of the Cost of communications, computer etc. (% of service exports) in Hong Kong in 2010 to that in 2011?
Keep it short and to the point. 1.06. What is the ratio of the Cost of communications, computer etc. (% of service exports) in United States in 2010 to that in 2011?
Your response must be concise. 0.98. What is the ratio of the Cost of communications, computer etc. (% of service exports) in Cambodia in 2010 to that in 2012?
Offer a very short reply. 1.01. What is the ratio of the Cost of communications, computer etc. (% of service exports) in Hong Kong in 2010 to that in 2012?
Offer a terse response. 1.05. What is the ratio of the Cost of communications, computer etc. (% of service exports) in United States in 2010 to that in 2012?
Give a very brief answer. 0.99. What is the ratio of the Cost of communications, computer etc. (% of service exports) of Cambodia in 2010 to that in 2013?
Give a very brief answer. 0.93. What is the ratio of the Cost of communications, computer etc. (% of service exports) of Hong Kong in 2010 to that in 2013?
Your response must be concise. 1.11. What is the ratio of the Cost of communications, computer etc. (% of service exports) of United States in 2010 to that in 2013?
Provide a succinct answer. 1.02. What is the ratio of the Cost of communications, computer etc. (% of service exports) of Cambodia in 2011 to that in 2012?
Offer a very short reply. 0.97. What is the ratio of the Cost of communications, computer etc. (% of service exports) in Hong Kong in 2011 to that in 2012?
Offer a very short reply. 0.99. What is the ratio of the Cost of communications, computer etc. (% of service exports) of Cambodia in 2011 to that in 2013?
Your response must be concise. 0.89. What is the ratio of the Cost of communications, computer etc. (% of service exports) of Hong Kong in 2011 to that in 2013?
Ensure brevity in your answer.  1.04. What is the ratio of the Cost of communications, computer etc. (% of service exports) in United States in 2011 to that in 2013?
Make the answer very short. 1.04. What is the ratio of the Cost of communications, computer etc. (% of service exports) in Cambodia in 2012 to that in 2013?
Your answer should be very brief. 0.92. What is the ratio of the Cost of communications, computer etc. (% of service exports) in Hong Kong in 2012 to that in 2013?
Offer a very short reply. 1.05. What is the ratio of the Cost of communications, computer etc. (% of service exports) in United States in 2012 to that in 2013?
Provide a succinct answer. 1.04. What is the difference between the highest and the second highest Cost of communications, computer etc. (% of service exports) of Cambodia?
Offer a very short reply. 0.1. What is the difference between the highest and the second highest Cost of communications, computer etc. (% of service exports) in Hong Kong?
Provide a succinct answer. 0.25. What is the difference between the highest and the second highest Cost of communications, computer etc. (% of service exports) in United States?
Offer a terse response. 0.96. What is the difference between the highest and the lowest Cost of communications, computer etc. (% of service exports) in Cambodia?
Your answer should be very brief. 1.65. What is the difference between the highest and the lowest Cost of communications, computer etc. (% of service exports) in Hong Kong?
Provide a succinct answer. 3.3. What is the difference between the highest and the lowest Cost of communications, computer etc. (% of service exports) in United States?
Provide a succinct answer. 2.88. 